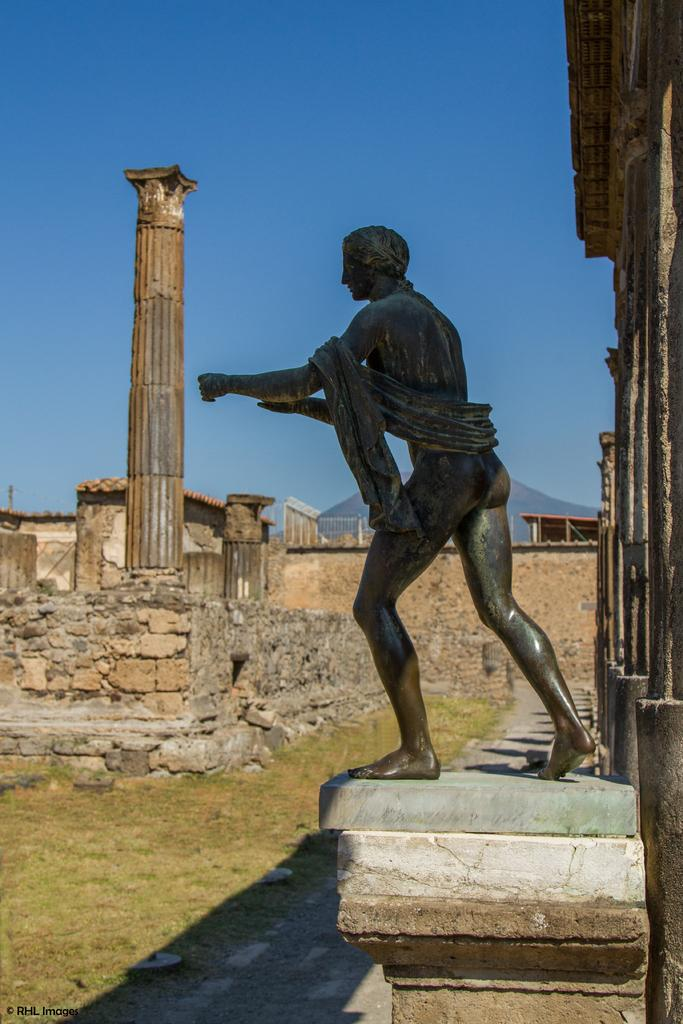What is the main subject of the image? The main subject of the image is a statue of a man on a wall. What is located behind the statue? There are stone pillars behind the statue. What type of structures can be seen behind the statue? There are homes visible behind the statue. What is visible above the statue? The sky is visible above the statue. What type of board game is being played under the statue in the image? There is no board game or any indication of a game being played in the image. 